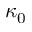<formula> <loc_0><loc_0><loc_500><loc_500>\kappa _ { 0 }</formula> 